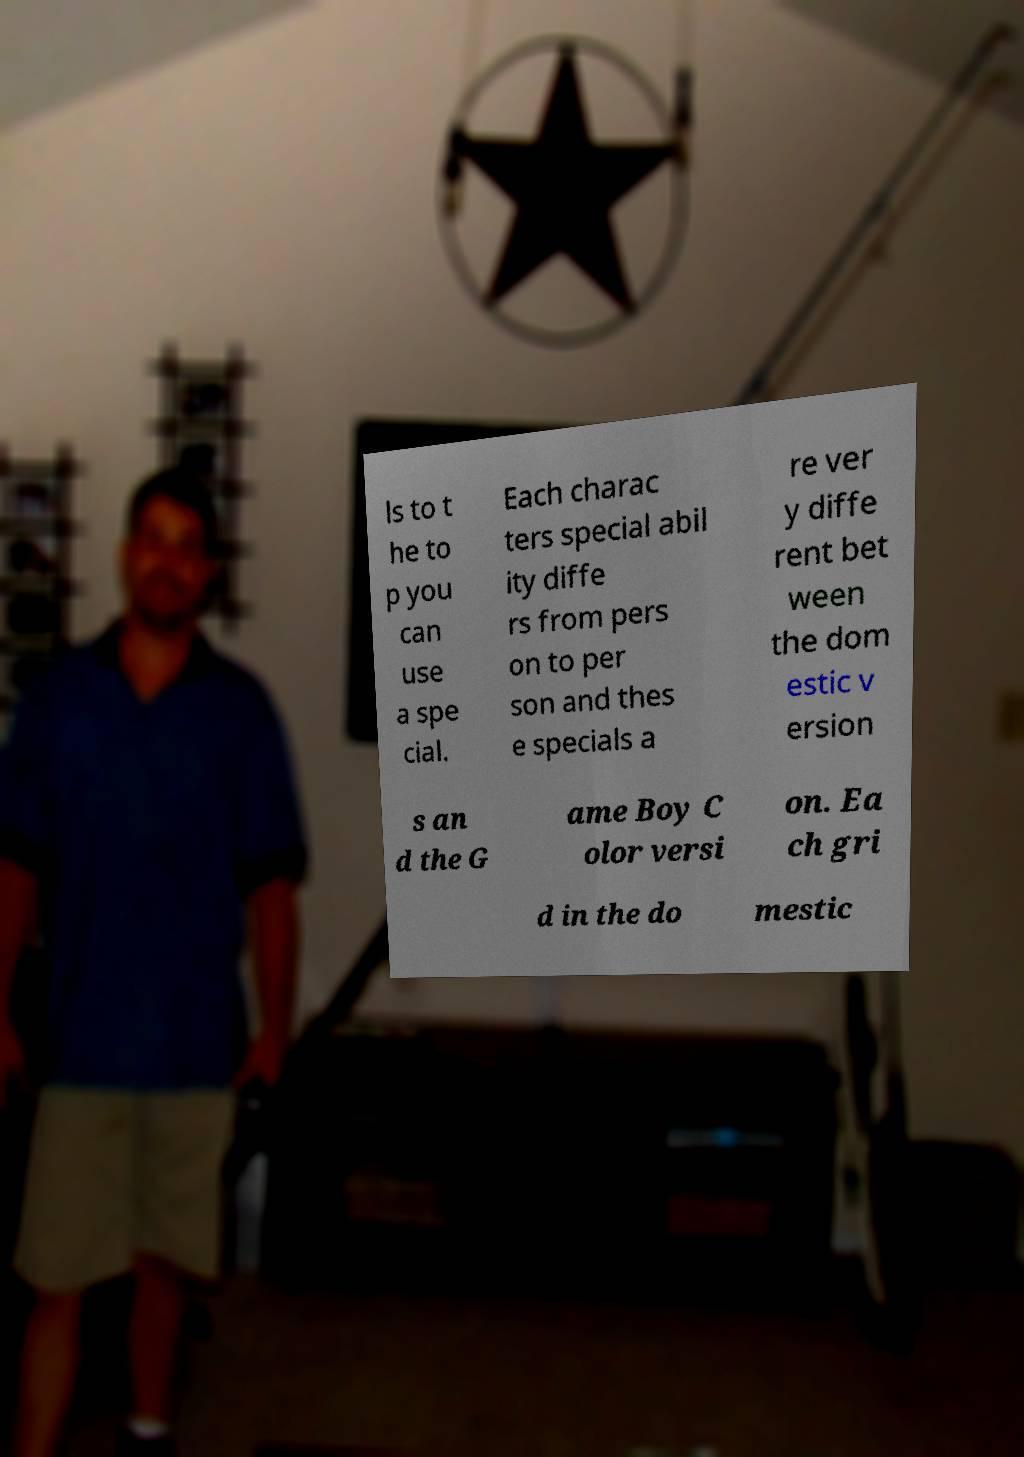For documentation purposes, I need the text within this image transcribed. Could you provide that? ls to t he to p you can use a spe cial. Each charac ters special abil ity diffe rs from pers on to per son and thes e specials a re ver y diffe rent bet ween the dom estic v ersion s an d the G ame Boy C olor versi on. Ea ch gri d in the do mestic 